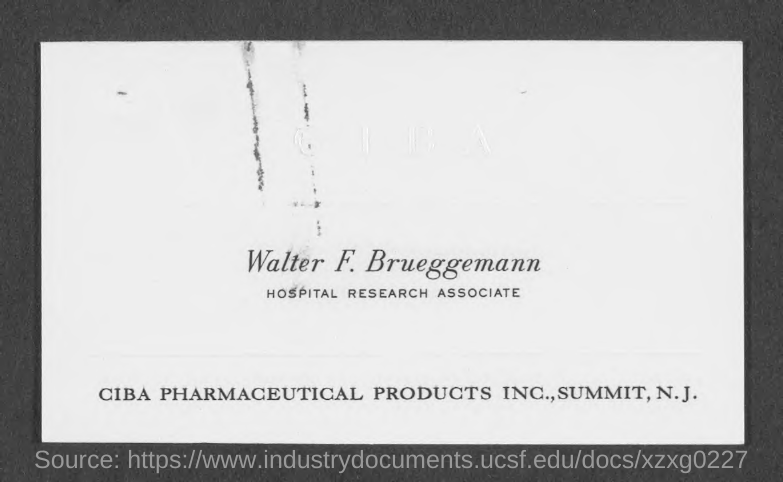What is the designation of "Walter F. Brueggemann"?
Offer a very short reply. HOSPITAL RESEARCH ASSOCIATE. Who is "HOSPITAL RESEARCH ASSOCIATE"?
Offer a terse response. Walter F. Brueggemann. 